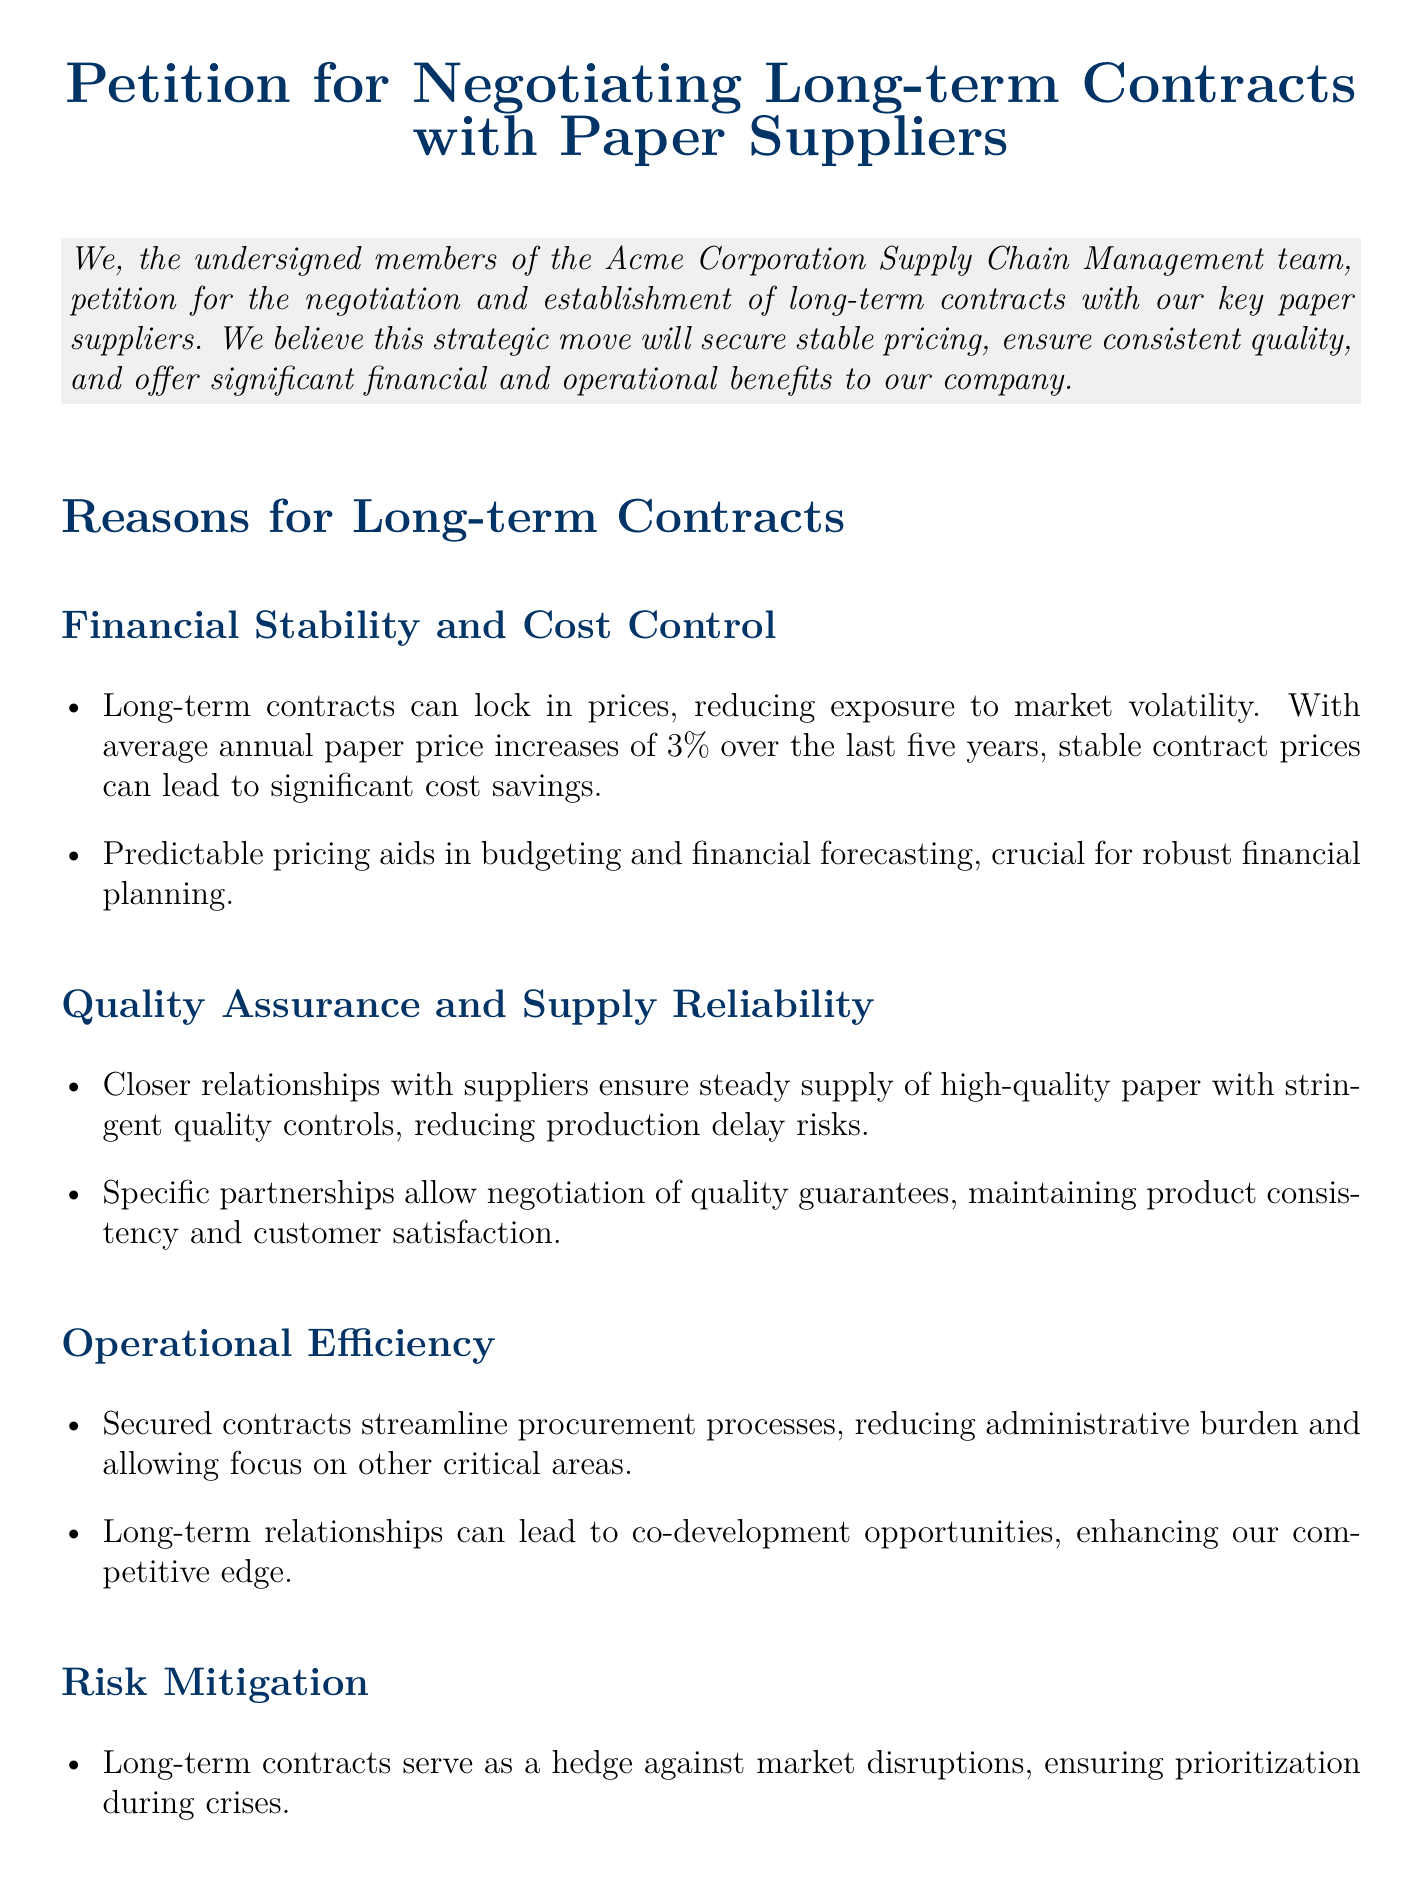What is the title of the document? The title is prominently displayed at the top of the document.
Answer: Petition for Negotiating Long-term Contracts with Paper Suppliers Who is the primary author of the petition? The author is mentioned in the signatories section of the document.
Answer: John Doe What is the average annual paper price increase mentioned? The document states a specific percentage related to price increases over several years.
Answer: 3% Which section discusses financial stability and cost control? The section is clearly labeled in the document, indicating its content focus.
Answer: Financial Stability and Cost Control What is one benefit of long-term contracts related to supply? The document lists several benefits related to supply relationships in one of the sections.
Answer: Supply Reliability How many signatories are listed at the end of the document? The total number of individuals who signed is found in the signatories section.
Answer: Three What type of action is being urged in the conclusion? The conclusion specifies a call to action regarding negotiations with suppliers.
Answer: Prompt action What is one reason for retaining quality in the documents? The document provides a rationale within the quality assurance section regarding the importance of quality.
Answer: Customer satisfaction 